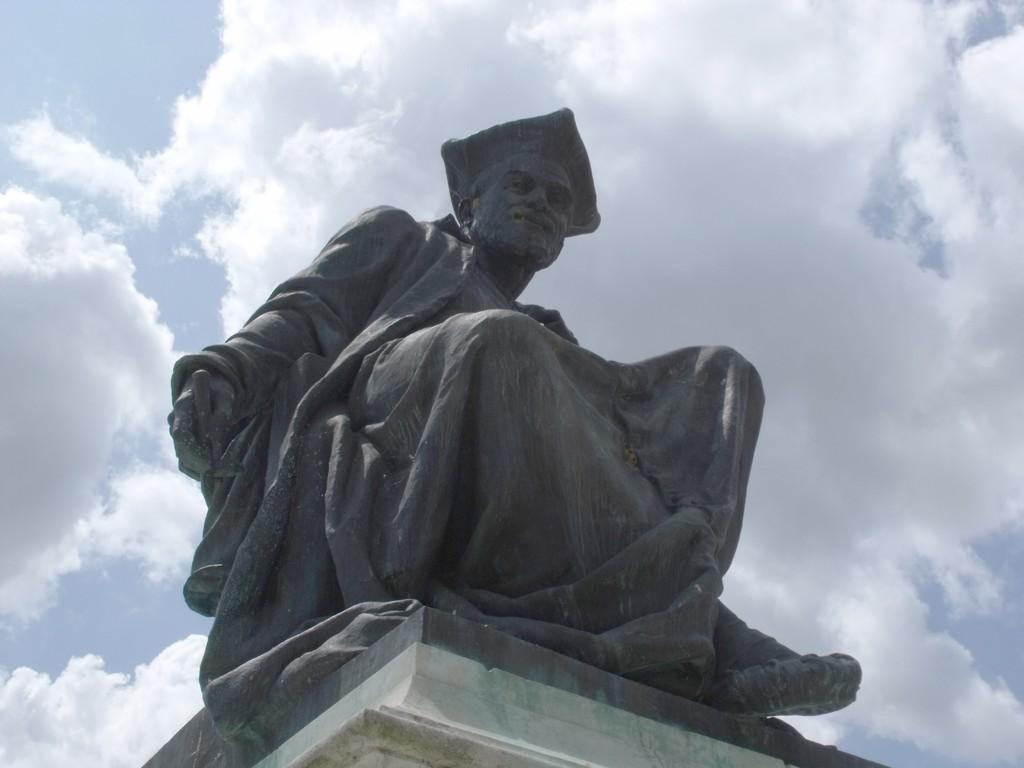What is the main subject in the image? There is a statue in the image. What is the statue standing on? There is a pedestal in the image. What can be seen in the background of the image? The sky is visible in the background of the image. What is the condition of the sky in the image? Clouds are present in the sky in the background of the image. What type of comb is the statue using in the image? There is no comb present in the image; it features a statue standing on a pedestal with a cloudy sky in the background. 